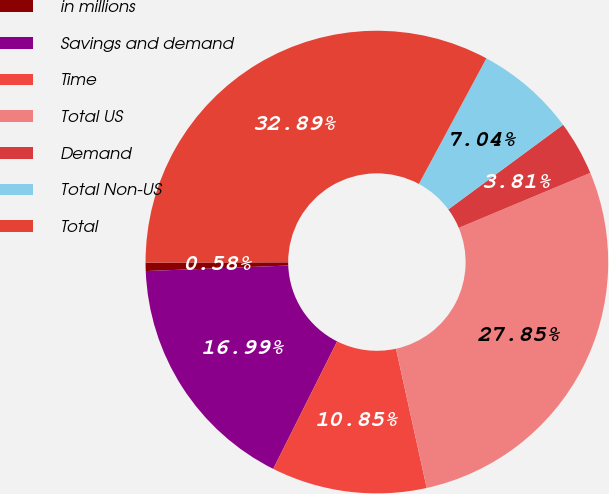Convert chart to OTSL. <chart><loc_0><loc_0><loc_500><loc_500><pie_chart><fcel>in millions<fcel>Savings and demand<fcel>Time<fcel>Total US<fcel>Demand<fcel>Total Non-US<fcel>Total<nl><fcel>0.58%<fcel>16.99%<fcel>10.85%<fcel>27.85%<fcel>3.81%<fcel>7.04%<fcel>32.89%<nl></chart> 